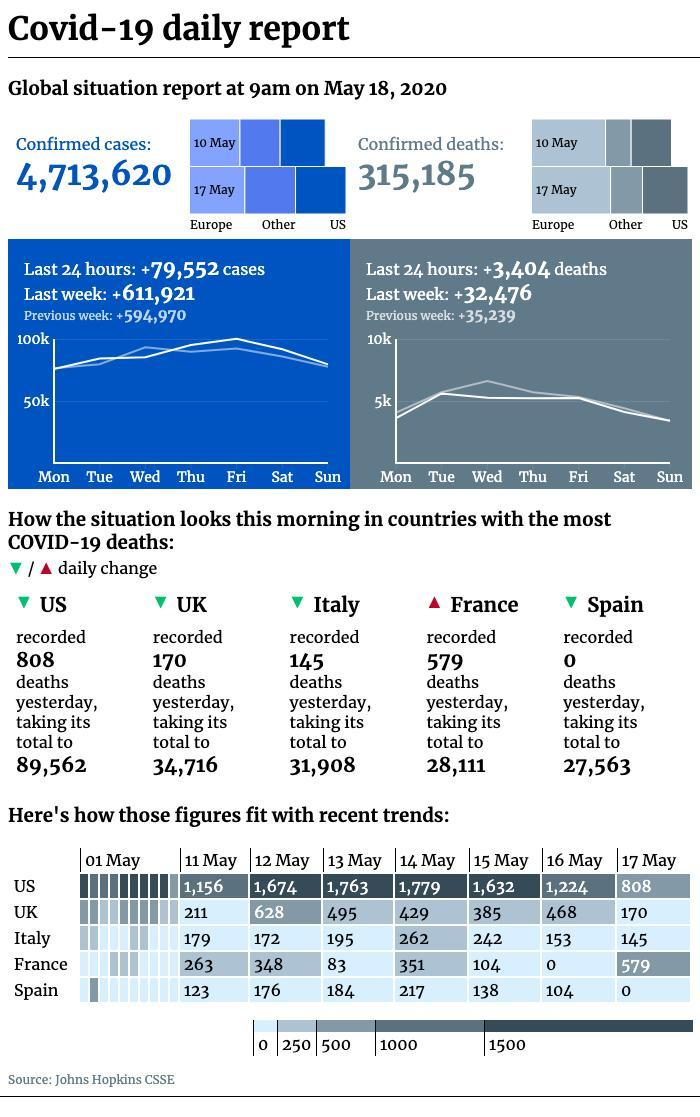What is the number of confirmed cases of COVID-19 reported globally as of May 18, 2020?
Answer the question with a short phrase. 4,713,620 What is the total number of COVID-19 deaths reported in the UK as of May 18, 2020? 34,716 How many confirmed Covid-19 deaths were reported globally as of May 18, 2020? 315,185 What is the total number of COVID-19 deaths reported in Italy as of May 18, 2020? 31,908 Which country has reported the least number of COVID-19 deaths among the given countries as of May 18, 2020? Spain Which country has reported the highest number of COVID-19 deaths among the  given countries as of May 18, 2020? US 